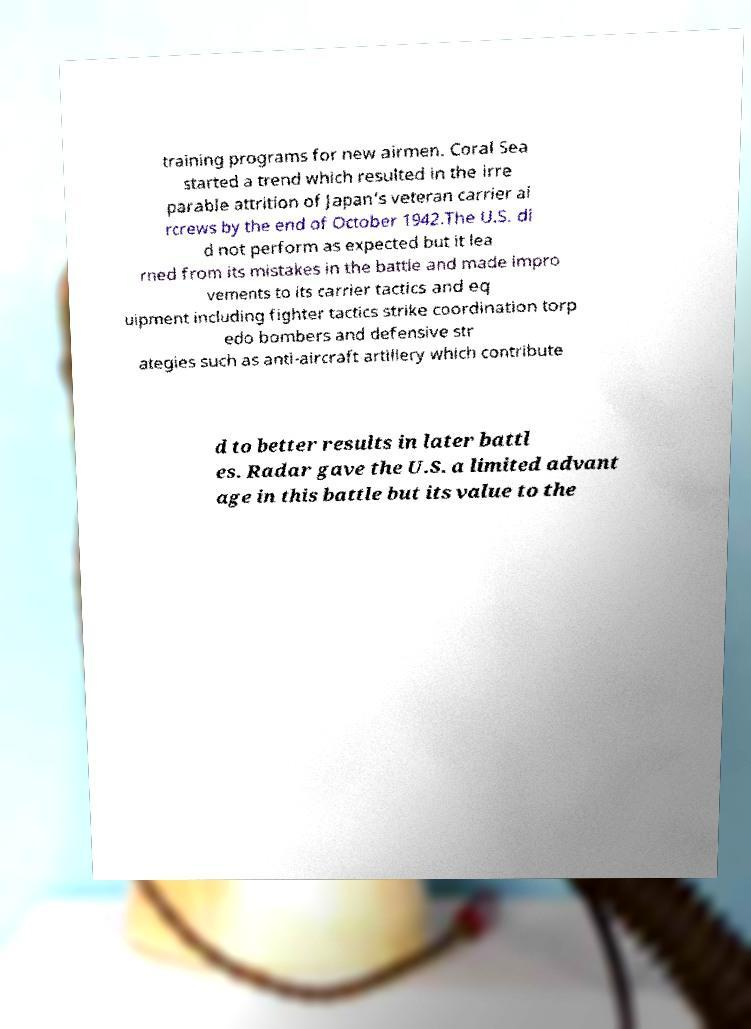There's text embedded in this image that I need extracted. Can you transcribe it verbatim? training programs for new airmen. Coral Sea started a trend which resulted in the irre parable attrition of Japan's veteran carrier ai rcrews by the end of October 1942.The U.S. di d not perform as expected but it lea rned from its mistakes in the battle and made impro vements to its carrier tactics and eq uipment including fighter tactics strike coordination torp edo bombers and defensive str ategies such as anti-aircraft artillery which contribute d to better results in later battl es. Radar gave the U.S. a limited advant age in this battle but its value to the 